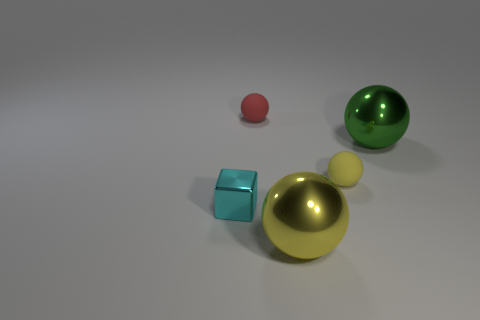Subtract all red balls. How many balls are left? 3 Subtract all green cubes. How many yellow spheres are left? 2 Add 4 tiny purple cylinders. How many objects exist? 9 Subtract all green spheres. How many spheres are left? 3 Subtract all blue balls. Subtract all brown cylinders. How many balls are left? 4 Subtract all blocks. How many objects are left? 4 Add 2 purple shiny cylinders. How many purple shiny cylinders exist? 2 Subtract 0 blue cubes. How many objects are left? 5 Subtract all large cyan things. Subtract all tiny cyan metal blocks. How many objects are left? 4 Add 2 tiny blocks. How many tiny blocks are left? 3 